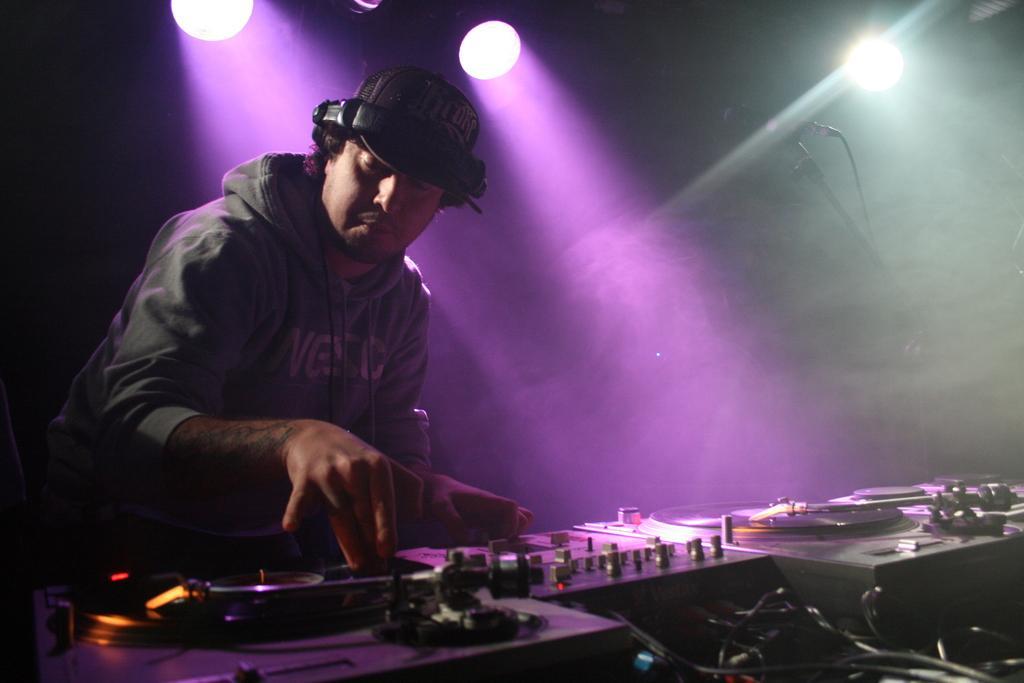Can you describe this image briefly? On the left we can see a man and there is a cap and headset on his head. At the bottom there are electronic devices and cables. In the background there are lights,mic on a stand and smoke. 